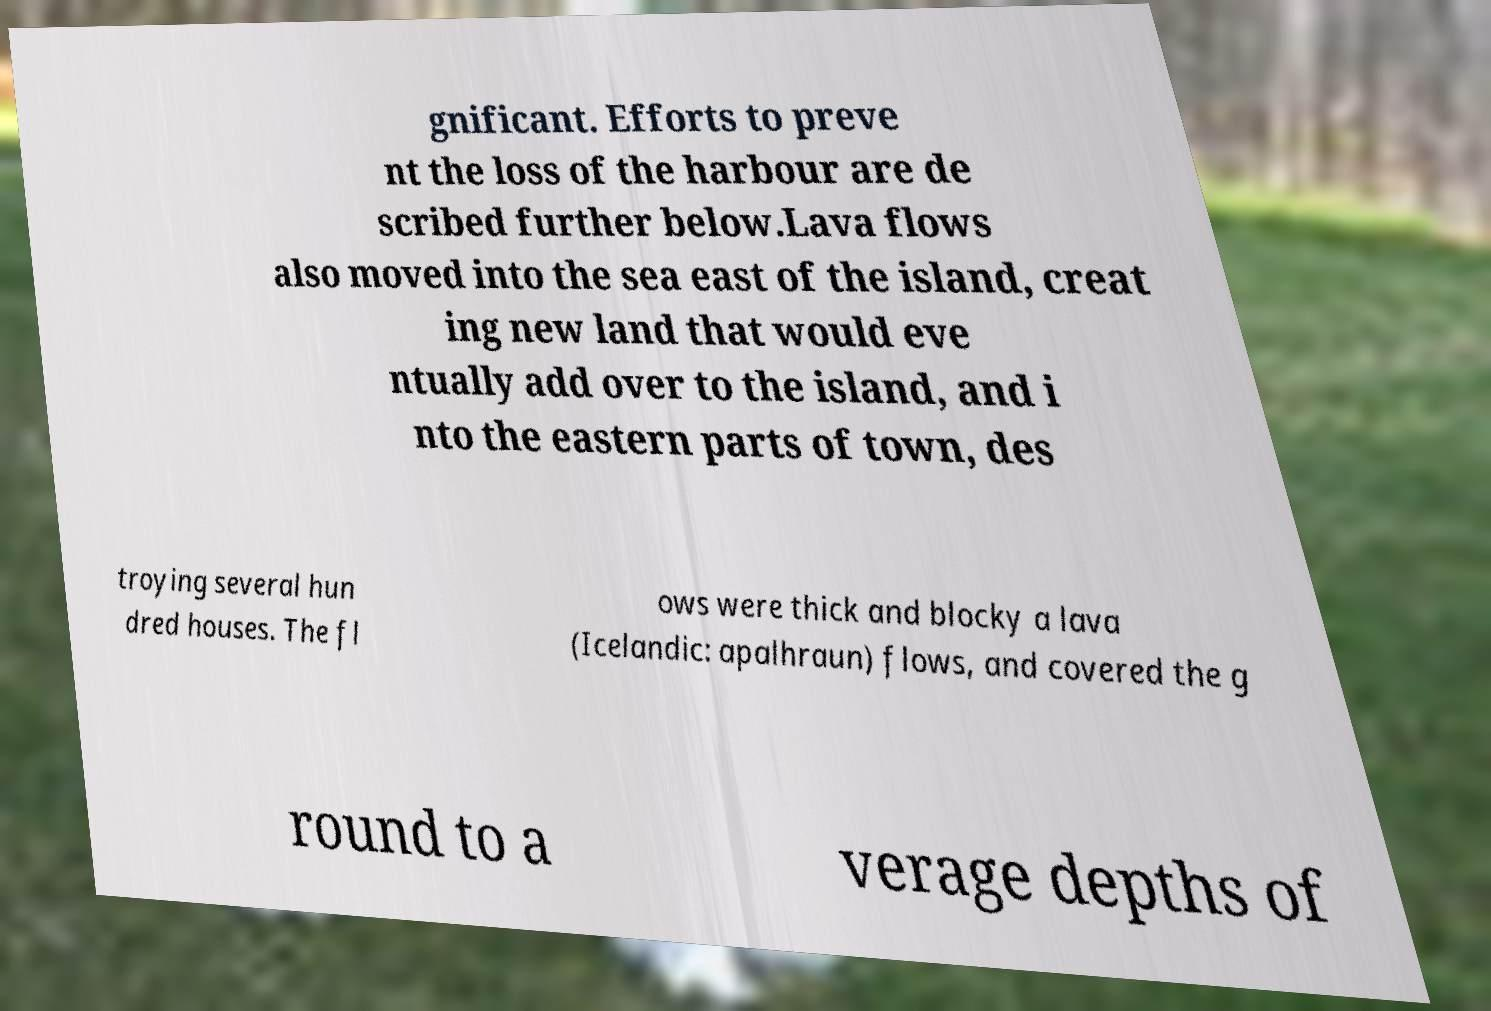What messages or text are displayed in this image? I need them in a readable, typed format. gnificant. Efforts to preve nt the loss of the harbour are de scribed further below.Lava flows also moved into the sea east of the island, creat ing new land that would eve ntually add over to the island, and i nto the eastern parts of town, des troying several hun dred houses. The fl ows were thick and blocky a lava (Icelandic: apalhraun) flows, and covered the g round to a verage depths of 